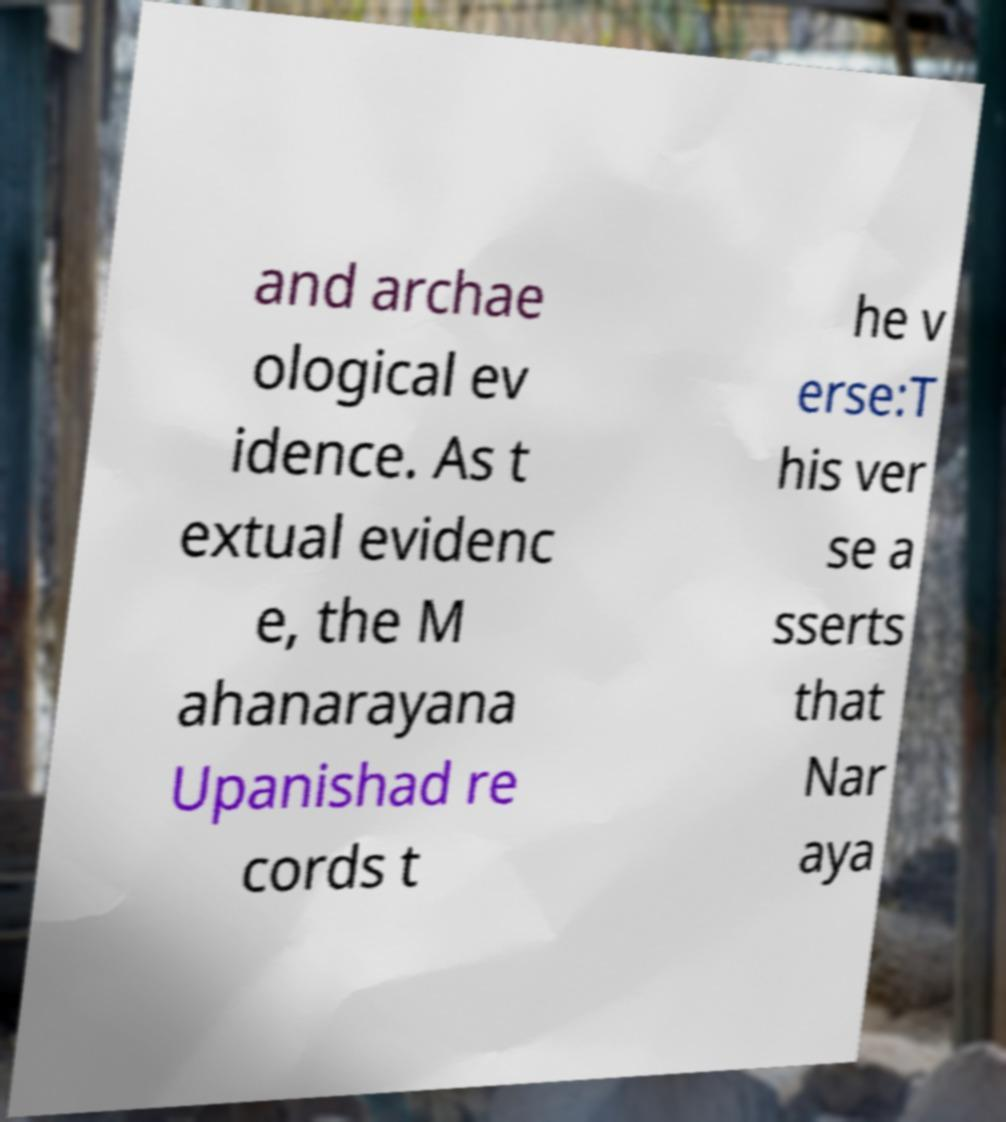Could you assist in decoding the text presented in this image and type it out clearly? and archae ological ev idence. As t extual evidenc e, the M ahanarayana Upanishad re cords t he v erse:T his ver se a sserts that Nar aya 